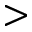<formula> <loc_0><loc_0><loc_500><loc_500>></formula> 